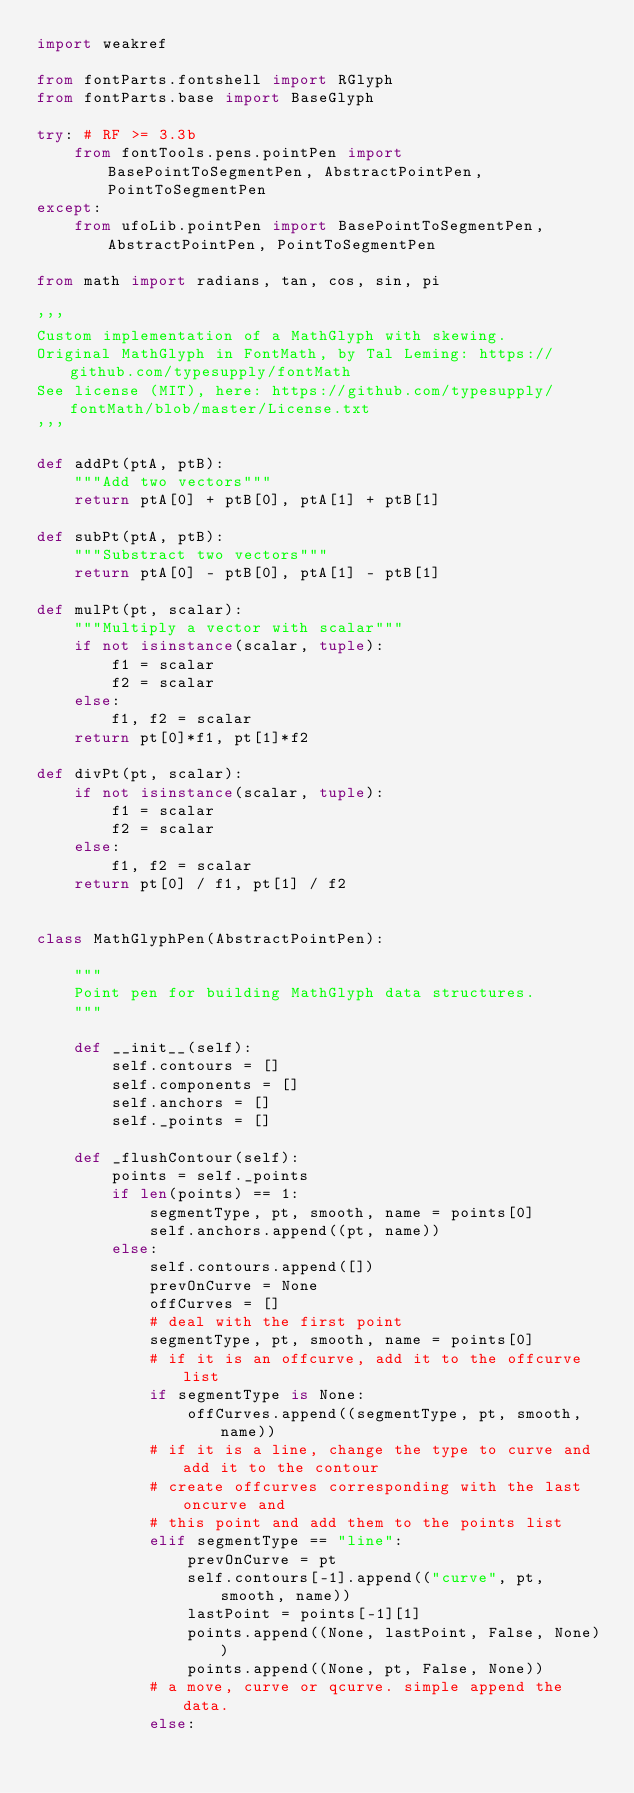<code> <loc_0><loc_0><loc_500><loc_500><_Python_>import weakref

from fontParts.fontshell import RGlyph
from fontParts.base import BaseGlyph

try: # RF >= 3.3b
    from fontTools.pens.pointPen import BasePointToSegmentPen, AbstractPointPen, PointToSegmentPen
except:
    from ufoLib.pointPen import BasePointToSegmentPen, AbstractPointPen, PointToSegmentPen

from math import radians, tan, cos, sin, pi

'''
Custom implementation of a MathGlyph with skewing.
Original MathGlyph in FontMath, by Tal Leming: https://github.com/typesupply/fontMath
See license (MIT), here: https://github.com/typesupply/fontMath/blob/master/License.txt
'''

def addPt(ptA, ptB):
    """Add two vectors"""
    return ptA[0] + ptB[0], ptA[1] + ptB[1]

def subPt(ptA, ptB):
    """Substract two vectors"""
    return ptA[0] - ptB[0], ptA[1] - ptB[1]

def mulPt(pt, scalar):
    """Multiply a vector with scalar"""
    if not isinstance(scalar, tuple):
        f1 = scalar
        f2 = scalar
    else:
        f1, f2 = scalar
    return pt[0]*f1, pt[1]*f2

def divPt(pt, scalar):
    if not isinstance(scalar, tuple):
        f1 = scalar
        f2 = scalar
    else:
        f1, f2 = scalar
    return pt[0] / f1, pt[1] / f2


class MathGlyphPen(AbstractPointPen):

    """
    Point pen for building MathGlyph data structures.
    """

    def __init__(self):
        self.contours = []
        self.components = []
        self.anchors = []
        self._points = []

    def _flushContour(self):
        points = self._points
        if len(points) == 1:
            segmentType, pt, smooth, name = points[0]
            self.anchors.append((pt, name))
        else:
            self.contours.append([])
            prevOnCurve = None
            offCurves = []
            # deal with the first point
            segmentType, pt, smooth, name = points[0]
            # if it is an offcurve, add it to the offcurve list
            if segmentType is None:
                offCurves.append((segmentType, pt, smooth, name))
            # if it is a line, change the type to curve and add it to the contour
            # create offcurves corresponding with the last oncurve and
            # this point and add them to the points list
            elif segmentType == "line":
                prevOnCurve = pt
                self.contours[-1].append(("curve", pt, smooth, name))
                lastPoint = points[-1][1]
                points.append((None, lastPoint, False, None))
                points.append((None, pt, False, None))
            # a move, curve or qcurve. simple append the data.
            else:</code> 